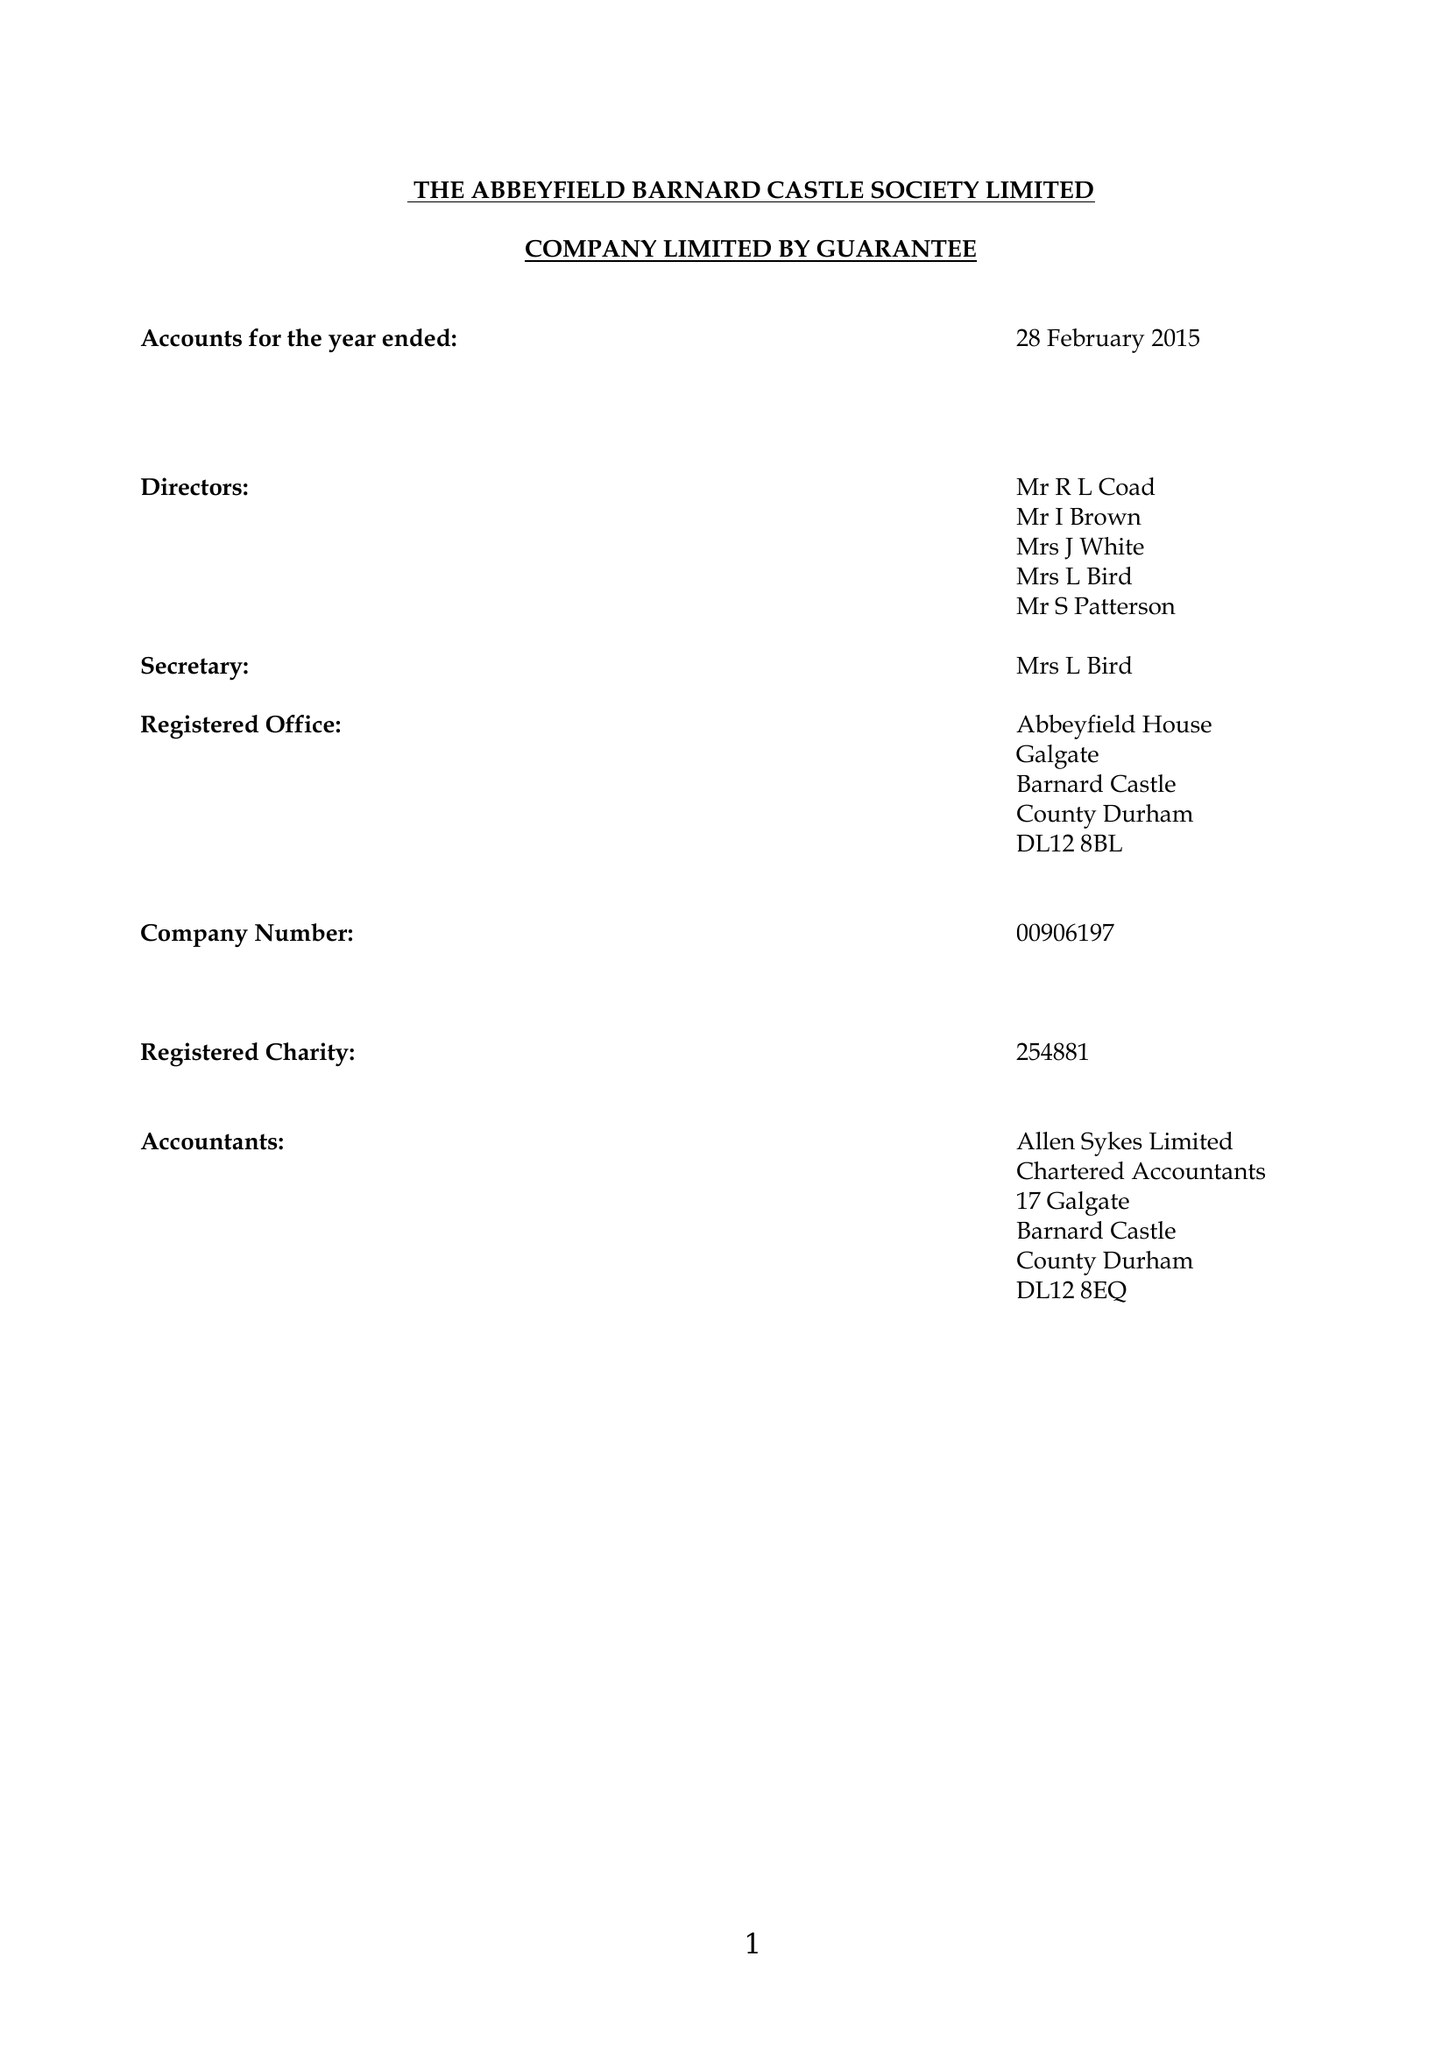What is the value for the report_date?
Answer the question using a single word or phrase. 2015-02-28 